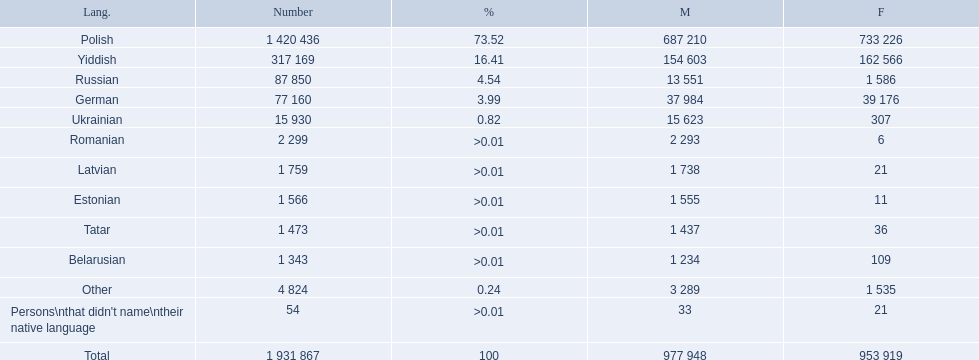What are all of the languages Polish, Yiddish, Russian, German, Ukrainian, Romanian, Latvian, Estonian, Tatar, Belarusian, Other, Persons\nthat didn't name\ntheir native language. What was the percentage of each? 73.52, 16.41, 4.54, 3.99, 0.82, >0.01, >0.01, >0.01, >0.01, >0.01, 0.24, >0.01. Which languages had a >0.01	 percentage? Romanian, Latvian, Estonian, Tatar, Belarusian. And of those, which is listed first? Romanian. 